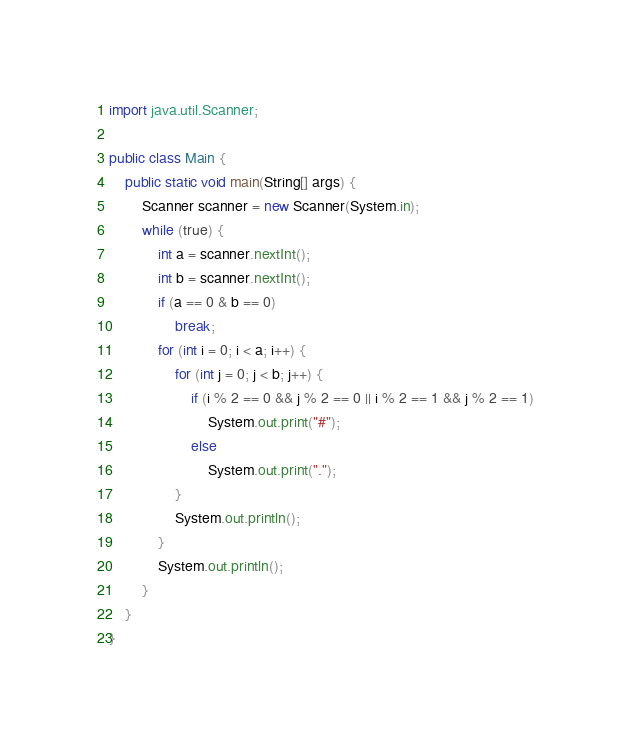<code> <loc_0><loc_0><loc_500><loc_500><_Java_>import java.util.Scanner;
 
public class Main {
    public static void main(String[] args) {
        Scanner scanner = new Scanner(System.in);
        while (true) {
            int a = scanner.nextInt();
            int b = scanner.nextInt();
            if (a == 0 & b == 0)
                break;
            for (int i = 0; i < a; i++) {
                for (int j = 0; j < b; j++) {
                    if (i % 2 == 0 && j % 2 == 0 || i % 2 == 1 && j % 2 == 1)
                        System.out.print("#");
                    else
                        System.out.print(".");
                }
                System.out.println();
            }
            System.out.println();
        }
    }
}



</code> 